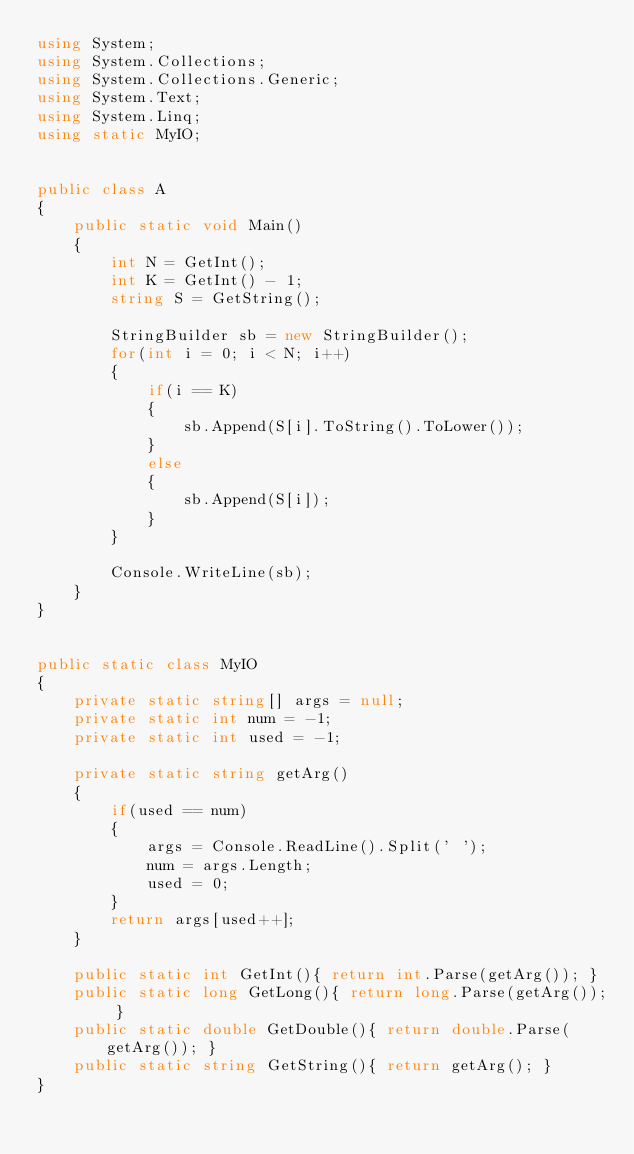<code> <loc_0><loc_0><loc_500><loc_500><_C#_>using System;
using System.Collections;
using System.Collections.Generic;
using System.Text;
using System.Linq;
using static MyIO;


public class A
{
	public static void Main()
	{
		int N = GetInt();
		int K = GetInt() - 1;
		string S = GetString();

		StringBuilder sb = new StringBuilder();
		for(int i = 0; i < N; i++)
		{
			if(i == K)
			{
				sb.Append(S[i].ToString().ToLower());
			}
			else
			{
				sb.Append(S[i]);
			}
		}

		Console.WriteLine(sb);
	}
}


public static class MyIO
{
	private static string[] args = null;
	private static int num = -1;
	private static int used = -1;

	private static string getArg()
	{
		if(used == num)
		{
			args = Console.ReadLine().Split(' ');
			num = args.Length;
			used = 0;
		}
		return args[used++];
	}

	public static int GetInt(){ return int.Parse(getArg()); }
	public static long GetLong(){ return long.Parse(getArg()); }
	public static double GetDouble(){ return double.Parse(getArg()); }
	public static string GetString(){ return getArg(); }
}</code> 